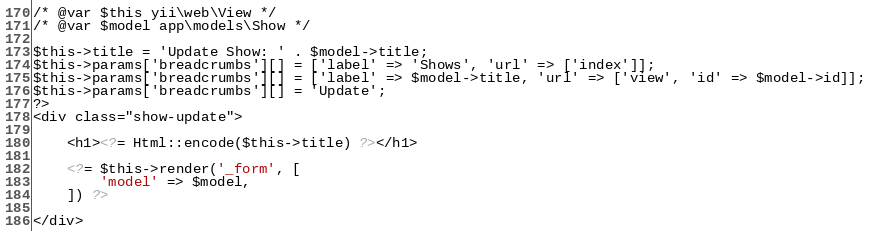Convert code to text. <code><loc_0><loc_0><loc_500><loc_500><_PHP_>
/* @var $this yii\web\View */
/* @var $model app\models\Show */

$this->title = 'Update Show: ' . $model->title;
$this->params['breadcrumbs'][] = ['label' => 'Shows', 'url' => ['index']];
$this->params['breadcrumbs'][] = ['label' => $model->title, 'url' => ['view', 'id' => $model->id]];
$this->params['breadcrumbs'][] = 'Update';
?>
<div class="show-update">

    <h1><?= Html::encode($this->title) ?></h1>

    <?= $this->render('_form', [
        'model' => $model,
    ]) ?>

</div>
</code> 